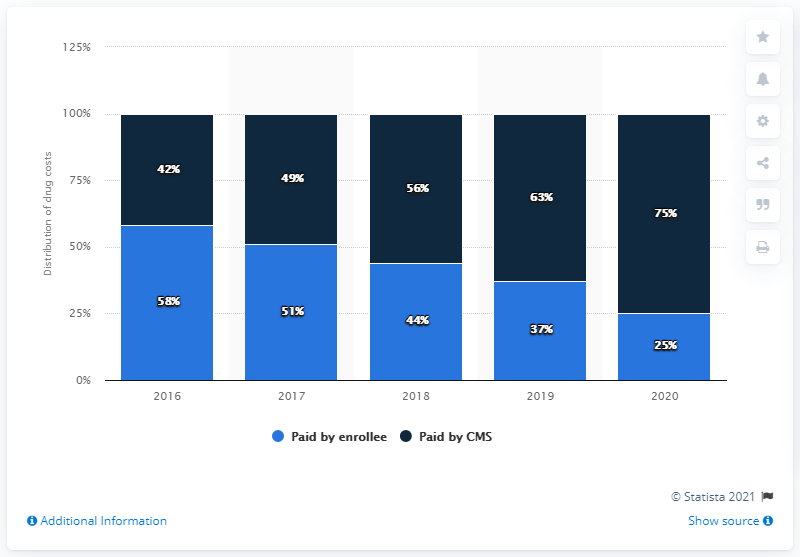Specify some key components in this picture. The percentage of paid by enrollee reached its peak in 2016. In 2016 and 2017, more than 50% of enrollees paid for their insurance coverage. 